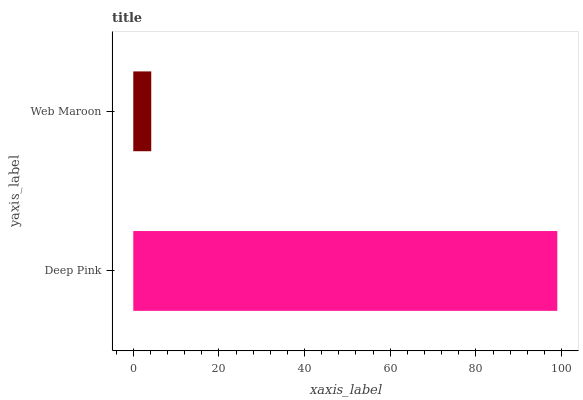Is Web Maroon the minimum?
Answer yes or no. Yes. Is Deep Pink the maximum?
Answer yes or no. Yes. Is Web Maroon the maximum?
Answer yes or no. No. Is Deep Pink greater than Web Maroon?
Answer yes or no. Yes. Is Web Maroon less than Deep Pink?
Answer yes or no. Yes. Is Web Maroon greater than Deep Pink?
Answer yes or no. No. Is Deep Pink less than Web Maroon?
Answer yes or no. No. Is Deep Pink the high median?
Answer yes or no. Yes. Is Web Maroon the low median?
Answer yes or no. Yes. Is Web Maroon the high median?
Answer yes or no. No. Is Deep Pink the low median?
Answer yes or no. No. 